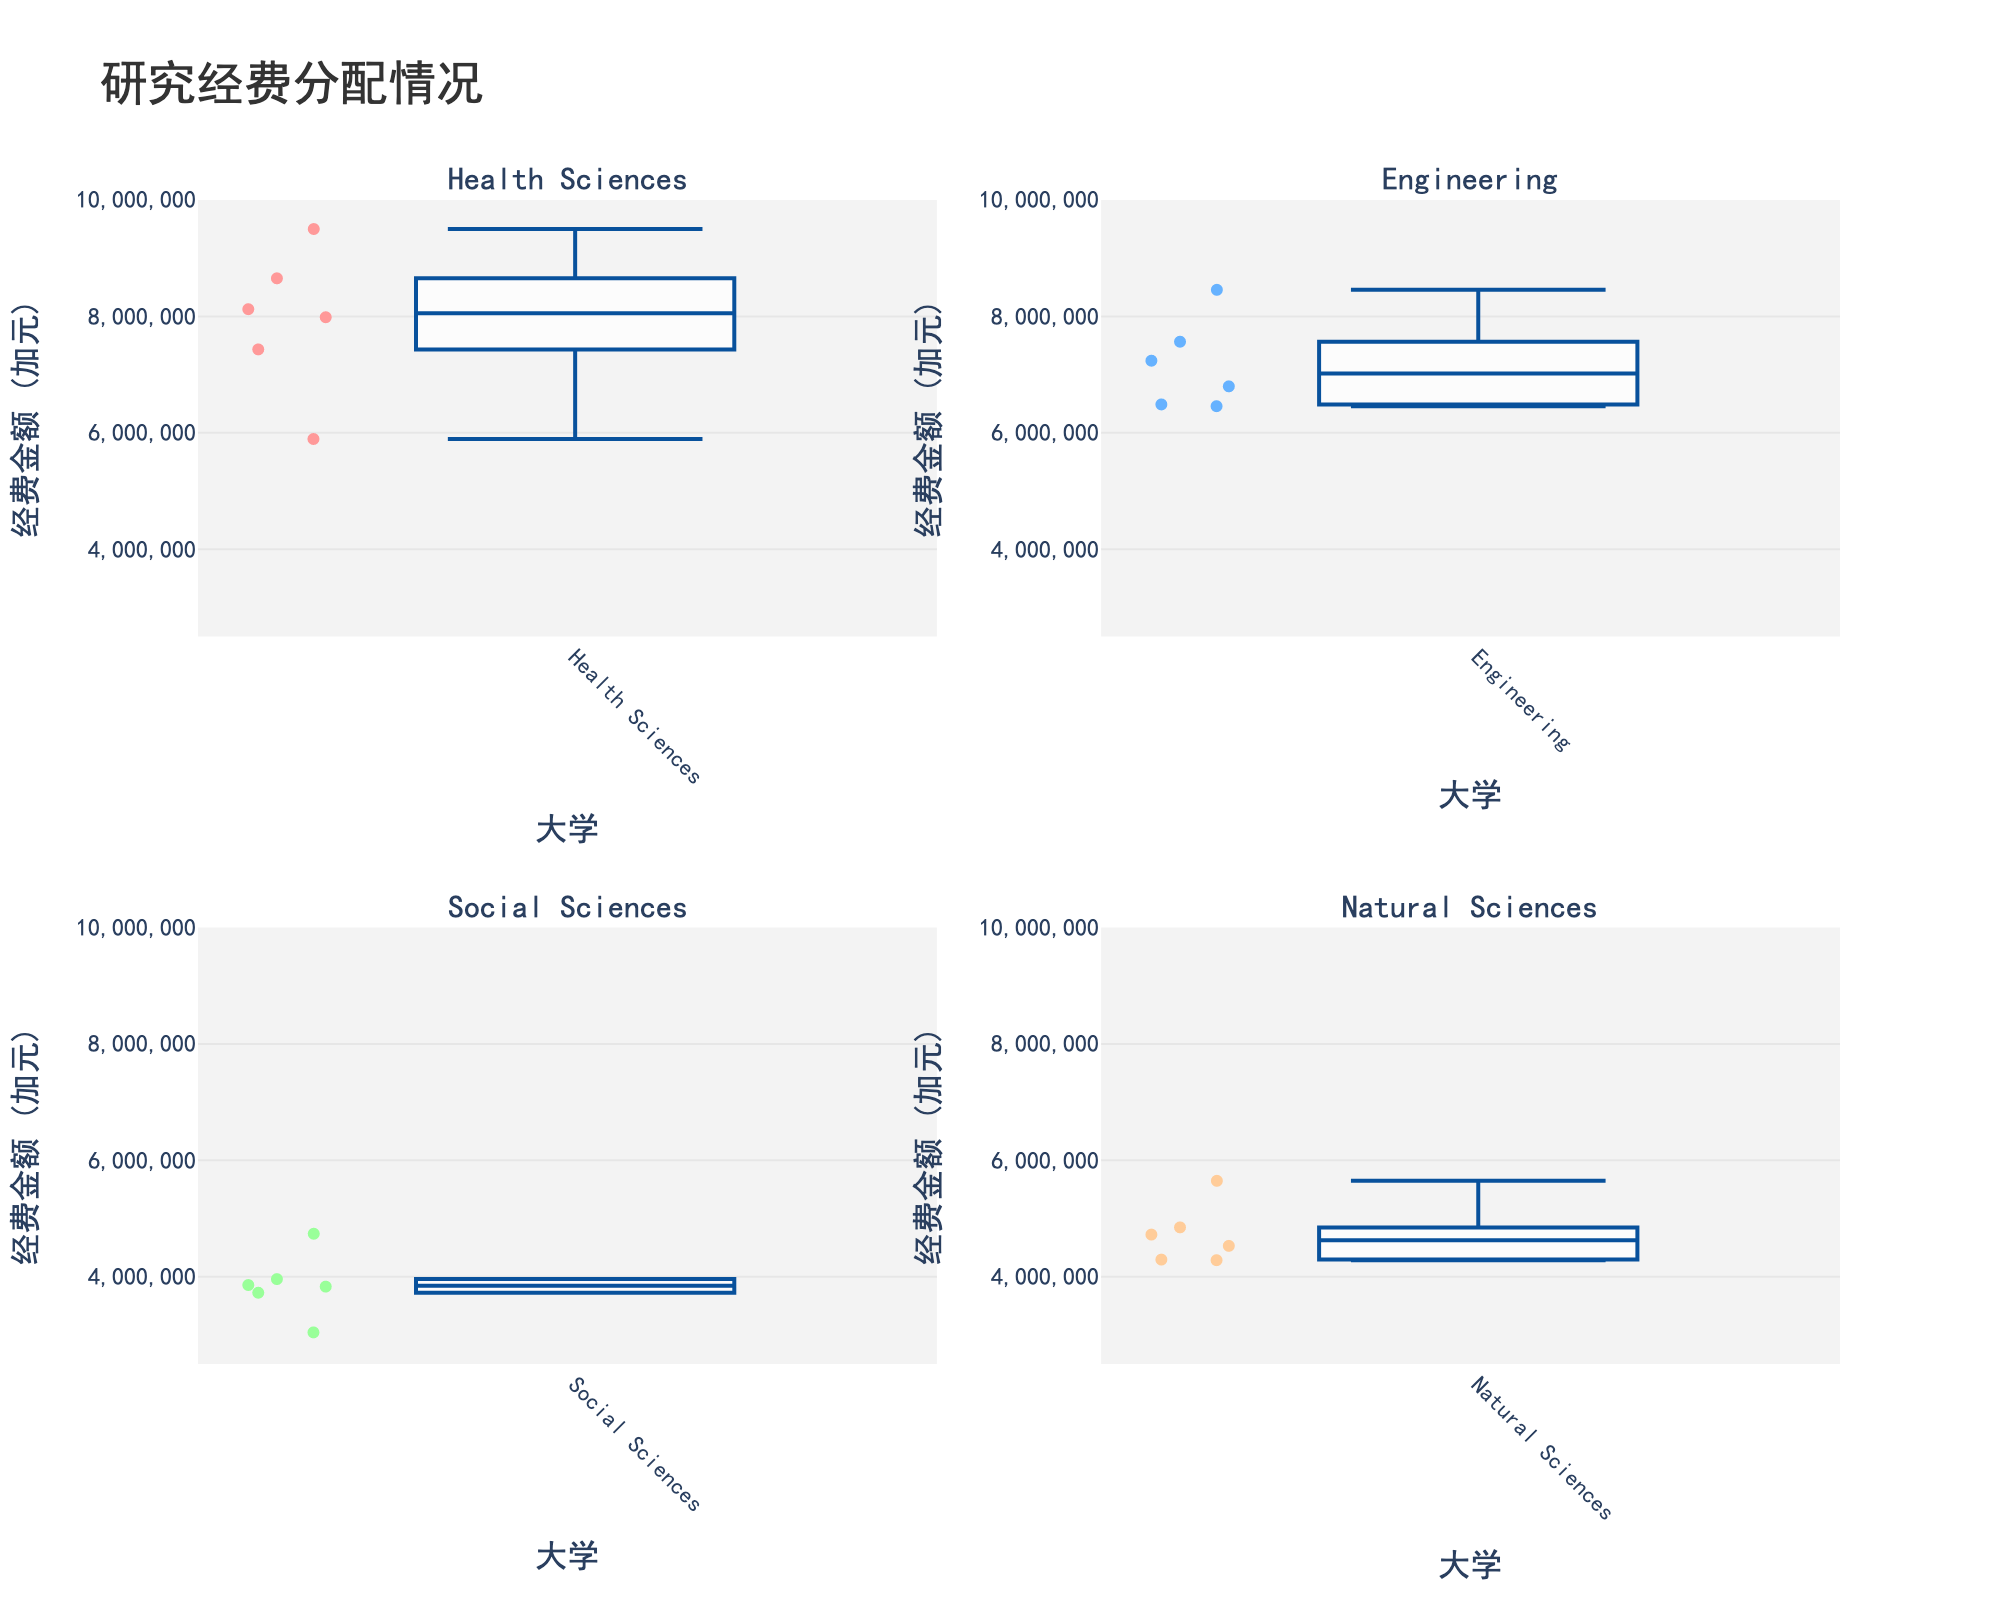Which university has the highest allocation for Health Sciences research funding? The box plot for Health Sciences shows different funding allocations, and the University of Toronto has the highest amount among them.
Answer: University of Toronto What is the title of the figure? The title of the figure is clearly written at the top of the plot.
Answer: 研究经费分配情况 Which funding category shows the widest range of research funding allocations? By comparing the length of the boxes and whiskers across subplots, the Health Sciences category appears to have the widest range.
Answer: Health Sciences Between McGill University and the University of Alberta, which one has a higher median funding amount in the Engineering category? Look at the median lines within the box plots for the Engineering category for McGill University and the University of Alberta. McGill University has a higher median.
Answer: McGill University How many universities are analyzed in the figure? Observe the distribution of data points across all subplots; five universities are represented: University of Toronto, University of British Columbia, McGill University, University of Alberta, and University of Waterloo, Université de Montréal.
Answer: 6 What is the median research funding amount for Natural Sciences? The median values are represented by the lines inside the boxes. For Natural Sciences, the median funding amount looks to be approximately 4800000.
Answer: 4800000 Which research funding category has the most consistent (least variable) funding across universities? By assessing the interquartile range (IQR) of the boxes, Social Sciences shows the least amount of spread, indicating it has the most consistent funding.
Answer: Social Sciences For the Engineering category, is the funding amount for the University of British Columbia higher than that for the University of Waterloo? Compare the data points in the Engineering box plot. The University of British Columbia has higher amount than University of Waterloo.
Answer: Yes What is the range of funding amounts for Social Sciences across all universities? The range is the difference between the maximum and minimum data points in the Social Sciences box plot, which varies from approximately 3000000 to 4800000.
Answer: 1800000 